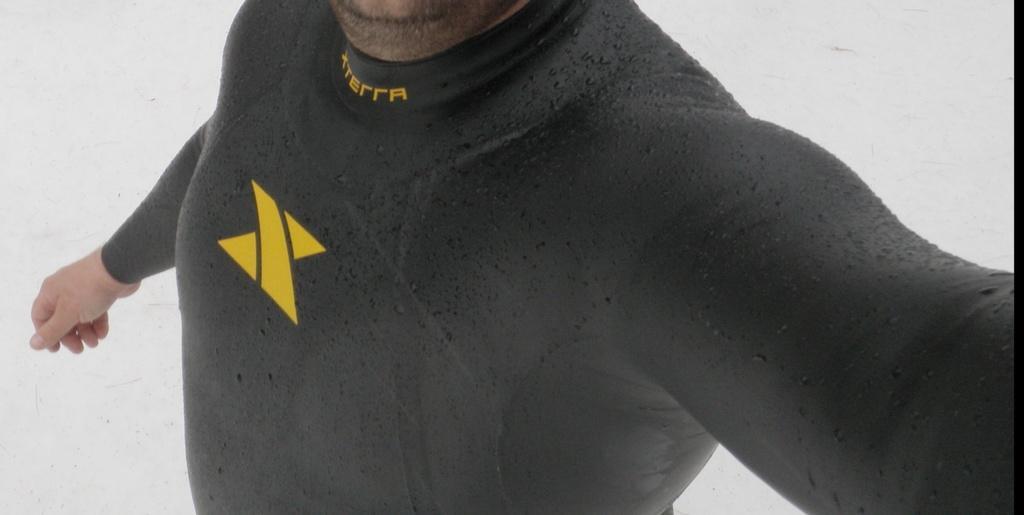Please provide a concise description of this image. In this image there is a person wearing a black top. Background is in white color. 